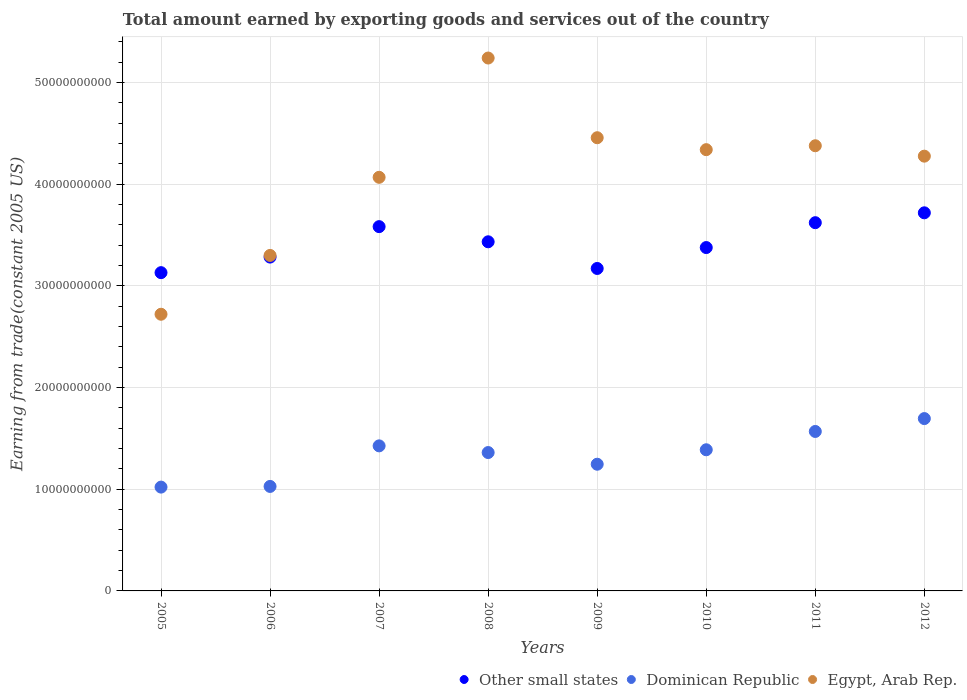What is the total amount earned by exporting goods and services in Egypt, Arab Rep. in 2012?
Make the answer very short. 4.28e+1. Across all years, what is the maximum total amount earned by exporting goods and services in Other small states?
Ensure brevity in your answer.  3.72e+1. Across all years, what is the minimum total amount earned by exporting goods and services in Egypt, Arab Rep.?
Offer a terse response. 2.72e+1. In which year was the total amount earned by exporting goods and services in Other small states maximum?
Keep it short and to the point. 2012. What is the total total amount earned by exporting goods and services in Other small states in the graph?
Make the answer very short. 2.73e+11. What is the difference between the total amount earned by exporting goods and services in Egypt, Arab Rep. in 2007 and that in 2008?
Keep it short and to the point. -1.17e+1. What is the difference between the total amount earned by exporting goods and services in Other small states in 2011 and the total amount earned by exporting goods and services in Dominican Republic in 2008?
Provide a short and direct response. 2.26e+1. What is the average total amount earned by exporting goods and services in Dominican Republic per year?
Your answer should be compact. 1.34e+1. In the year 2006, what is the difference between the total amount earned by exporting goods and services in Egypt, Arab Rep. and total amount earned by exporting goods and services in Other small states?
Your answer should be very brief. 1.63e+08. What is the ratio of the total amount earned by exporting goods and services in Other small states in 2009 to that in 2012?
Offer a terse response. 0.85. Is the total amount earned by exporting goods and services in Egypt, Arab Rep. in 2007 less than that in 2008?
Give a very brief answer. Yes. Is the difference between the total amount earned by exporting goods and services in Egypt, Arab Rep. in 2008 and 2010 greater than the difference between the total amount earned by exporting goods and services in Other small states in 2008 and 2010?
Ensure brevity in your answer.  Yes. What is the difference between the highest and the second highest total amount earned by exporting goods and services in Other small states?
Your response must be concise. 9.71e+08. What is the difference between the highest and the lowest total amount earned by exporting goods and services in Other small states?
Your answer should be compact. 5.89e+09. In how many years, is the total amount earned by exporting goods and services in Other small states greater than the average total amount earned by exporting goods and services in Other small states taken over all years?
Ensure brevity in your answer.  4. Is the sum of the total amount earned by exporting goods and services in Dominican Republic in 2009 and 2010 greater than the maximum total amount earned by exporting goods and services in Egypt, Arab Rep. across all years?
Keep it short and to the point. No. Is it the case that in every year, the sum of the total amount earned by exporting goods and services in Dominican Republic and total amount earned by exporting goods and services in Other small states  is greater than the total amount earned by exporting goods and services in Egypt, Arab Rep.?
Your answer should be very brief. No. Is the total amount earned by exporting goods and services in Dominican Republic strictly less than the total amount earned by exporting goods and services in Egypt, Arab Rep. over the years?
Your answer should be very brief. Yes. What is the difference between two consecutive major ticks on the Y-axis?
Give a very brief answer. 1.00e+1. Does the graph contain grids?
Provide a succinct answer. Yes. Where does the legend appear in the graph?
Make the answer very short. Bottom right. What is the title of the graph?
Give a very brief answer. Total amount earned by exporting goods and services out of the country. What is the label or title of the Y-axis?
Make the answer very short. Earning from trade(constant 2005 US). What is the Earning from trade(constant 2005 US) in Other small states in 2005?
Your answer should be compact. 3.13e+1. What is the Earning from trade(constant 2005 US) of Dominican Republic in 2005?
Provide a short and direct response. 1.02e+1. What is the Earning from trade(constant 2005 US) in Egypt, Arab Rep. in 2005?
Ensure brevity in your answer.  2.72e+1. What is the Earning from trade(constant 2005 US) in Other small states in 2006?
Make the answer very short. 3.28e+1. What is the Earning from trade(constant 2005 US) in Dominican Republic in 2006?
Offer a very short reply. 1.03e+1. What is the Earning from trade(constant 2005 US) of Egypt, Arab Rep. in 2006?
Your answer should be very brief. 3.30e+1. What is the Earning from trade(constant 2005 US) in Other small states in 2007?
Offer a very short reply. 3.58e+1. What is the Earning from trade(constant 2005 US) of Dominican Republic in 2007?
Make the answer very short. 1.43e+1. What is the Earning from trade(constant 2005 US) in Egypt, Arab Rep. in 2007?
Your answer should be very brief. 4.07e+1. What is the Earning from trade(constant 2005 US) of Other small states in 2008?
Your answer should be compact. 3.43e+1. What is the Earning from trade(constant 2005 US) in Dominican Republic in 2008?
Provide a short and direct response. 1.36e+1. What is the Earning from trade(constant 2005 US) in Egypt, Arab Rep. in 2008?
Keep it short and to the point. 5.24e+1. What is the Earning from trade(constant 2005 US) of Other small states in 2009?
Provide a succinct answer. 3.17e+1. What is the Earning from trade(constant 2005 US) in Dominican Republic in 2009?
Your response must be concise. 1.25e+1. What is the Earning from trade(constant 2005 US) of Egypt, Arab Rep. in 2009?
Your answer should be very brief. 4.46e+1. What is the Earning from trade(constant 2005 US) in Other small states in 2010?
Your answer should be very brief. 3.38e+1. What is the Earning from trade(constant 2005 US) of Dominican Republic in 2010?
Offer a very short reply. 1.39e+1. What is the Earning from trade(constant 2005 US) of Egypt, Arab Rep. in 2010?
Make the answer very short. 4.34e+1. What is the Earning from trade(constant 2005 US) of Other small states in 2011?
Offer a terse response. 3.62e+1. What is the Earning from trade(constant 2005 US) in Dominican Republic in 2011?
Keep it short and to the point. 1.57e+1. What is the Earning from trade(constant 2005 US) in Egypt, Arab Rep. in 2011?
Your answer should be compact. 4.38e+1. What is the Earning from trade(constant 2005 US) in Other small states in 2012?
Offer a terse response. 3.72e+1. What is the Earning from trade(constant 2005 US) of Dominican Republic in 2012?
Your response must be concise. 1.70e+1. What is the Earning from trade(constant 2005 US) of Egypt, Arab Rep. in 2012?
Your answer should be very brief. 4.28e+1. Across all years, what is the maximum Earning from trade(constant 2005 US) in Other small states?
Provide a short and direct response. 3.72e+1. Across all years, what is the maximum Earning from trade(constant 2005 US) in Dominican Republic?
Keep it short and to the point. 1.70e+1. Across all years, what is the maximum Earning from trade(constant 2005 US) in Egypt, Arab Rep.?
Make the answer very short. 5.24e+1. Across all years, what is the minimum Earning from trade(constant 2005 US) of Other small states?
Offer a terse response. 3.13e+1. Across all years, what is the minimum Earning from trade(constant 2005 US) in Dominican Republic?
Provide a short and direct response. 1.02e+1. Across all years, what is the minimum Earning from trade(constant 2005 US) in Egypt, Arab Rep.?
Ensure brevity in your answer.  2.72e+1. What is the total Earning from trade(constant 2005 US) in Other small states in the graph?
Offer a very short reply. 2.73e+11. What is the total Earning from trade(constant 2005 US) of Dominican Republic in the graph?
Provide a short and direct response. 1.07e+11. What is the total Earning from trade(constant 2005 US) in Egypt, Arab Rep. in the graph?
Your response must be concise. 3.28e+11. What is the difference between the Earning from trade(constant 2005 US) in Other small states in 2005 and that in 2006?
Offer a terse response. -1.53e+09. What is the difference between the Earning from trade(constant 2005 US) in Dominican Republic in 2005 and that in 2006?
Ensure brevity in your answer.  -6.68e+07. What is the difference between the Earning from trade(constant 2005 US) of Egypt, Arab Rep. in 2005 and that in 2006?
Make the answer very short. -5.79e+09. What is the difference between the Earning from trade(constant 2005 US) of Other small states in 2005 and that in 2007?
Offer a very short reply. -4.53e+09. What is the difference between the Earning from trade(constant 2005 US) in Dominican Republic in 2005 and that in 2007?
Your response must be concise. -4.06e+09. What is the difference between the Earning from trade(constant 2005 US) of Egypt, Arab Rep. in 2005 and that in 2007?
Provide a succinct answer. -1.35e+1. What is the difference between the Earning from trade(constant 2005 US) in Other small states in 2005 and that in 2008?
Ensure brevity in your answer.  -3.04e+09. What is the difference between the Earning from trade(constant 2005 US) of Dominican Republic in 2005 and that in 2008?
Give a very brief answer. -3.40e+09. What is the difference between the Earning from trade(constant 2005 US) in Egypt, Arab Rep. in 2005 and that in 2008?
Your answer should be very brief. -2.52e+1. What is the difference between the Earning from trade(constant 2005 US) in Other small states in 2005 and that in 2009?
Provide a succinct answer. -4.12e+08. What is the difference between the Earning from trade(constant 2005 US) in Dominican Republic in 2005 and that in 2009?
Provide a short and direct response. -2.25e+09. What is the difference between the Earning from trade(constant 2005 US) in Egypt, Arab Rep. in 2005 and that in 2009?
Give a very brief answer. -1.74e+1. What is the difference between the Earning from trade(constant 2005 US) in Other small states in 2005 and that in 2010?
Ensure brevity in your answer.  -2.47e+09. What is the difference between the Earning from trade(constant 2005 US) in Dominican Republic in 2005 and that in 2010?
Your answer should be compact. -3.67e+09. What is the difference between the Earning from trade(constant 2005 US) of Egypt, Arab Rep. in 2005 and that in 2010?
Your answer should be very brief. -1.62e+1. What is the difference between the Earning from trade(constant 2005 US) of Other small states in 2005 and that in 2011?
Ensure brevity in your answer.  -4.91e+09. What is the difference between the Earning from trade(constant 2005 US) in Dominican Republic in 2005 and that in 2011?
Make the answer very short. -5.47e+09. What is the difference between the Earning from trade(constant 2005 US) of Egypt, Arab Rep. in 2005 and that in 2011?
Make the answer very short. -1.66e+1. What is the difference between the Earning from trade(constant 2005 US) of Other small states in 2005 and that in 2012?
Ensure brevity in your answer.  -5.89e+09. What is the difference between the Earning from trade(constant 2005 US) in Dominican Republic in 2005 and that in 2012?
Ensure brevity in your answer.  -6.74e+09. What is the difference between the Earning from trade(constant 2005 US) in Egypt, Arab Rep. in 2005 and that in 2012?
Provide a succinct answer. -1.56e+1. What is the difference between the Earning from trade(constant 2005 US) of Other small states in 2006 and that in 2007?
Keep it short and to the point. -2.99e+09. What is the difference between the Earning from trade(constant 2005 US) of Dominican Republic in 2006 and that in 2007?
Your answer should be compact. -3.99e+09. What is the difference between the Earning from trade(constant 2005 US) in Egypt, Arab Rep. in 2006 and that in 2007?
Provide a short and direct response. -7.68e+09. What is the difference between the Earning from trade(constant 2005 US) in Other small states in 2006 and that in 2008?
Provide a succinct answer. -1.50e+09. What is the difference between the Earning from trade(constant 2005 US) in Dominican Republic in 2006 and that in 2008?
Make the answer very short. -3.33e+09. What is the difference between the Earning from trade(constant 2005 US) of Egypt, Arab Rep. in 2006 and that in 2008?
Give a very brief answer. -1.94e+1. What is the difference between the Earning from trade(constant 2005 US) in Other small states in 2006 and that in 2009?
Make the answer very short. 1.12e+09. What is the difference between the Earning from trade(constant 2005 US) in Dominican Republic in 2006 and that in 2009?
Make the answer very short. -2.18e+09. What is the difference between the Earning from trade(constant 2005 US) in Egypt, Arab Rep. in 2006 and that in 2009?
Provide a succinct answer. -1.16e+1. What is the difference between the Earning from trade(constant 2005 US) of Other small states in 2006 and that in 2010?
Your answer should be compact. -9.37e+08. What is the difference between the Earning from trade(constant 2005 US) of Dominican Republic in 2006 and that in 2010?
Your response must be concise. -3.61e+09. What is the difference between the Earning from trade(constant 2005 US) of Egypt, Arab Rep. in 2006 and that in 2010?
Your answer should be compact. -1.04e+1. What is the difference between the Earning from trade(constant 2005 US) in Other small states in 2006 and that in 2011?
Provide a succinct answer. -3.38e+09. What is the difference between the Earning from trade(constant 2005 US) of Dominican Republic in 2006 and that in 2011?
Keep it short and to the point. -5.41e+09. What is the difference between the Earning from trade(constant 2005 US) of Egypt, Arab Rep. in 2006 and that in 2011?
Give a very brief answer. -1.08e+1. What is the difference between the Earning from trade(constant 2005 US) of Other small states in 2006 and that in 2012?
Provide a short and direct response. -4.35e+09. What is the difference between the Earning from trade(constant 2005 US) in Dominican Republic in 2006 and that in 2012?
Your answer should be very brief. -6.67e+09. What is the difference between the Earning from trade(constant 2005 US) in Egypt, Arab Rep. in 2006 and that in 2012?
Your response must be concise. -9.76e+09. What is the difference between the Earning from trade(constant 2005 US) in Other small states in 2007 and that in 2008?
Provide a short and direct response. 1.49e+09. What is the difference between the Earning from trade(constant 2005 US) in Dominican Republic in 2007 and that in 2008?
Give a very brief answer. 6.58e+08. What is the difference between the Earning from trade(constant 2005 US) in Egypt, Arab Rep. in 2007 and that in 2008?
Offer a terse response. -1.17e+1. What is the difference between the Earning from trade(constant 2005 US) of Other small states in 2007 and that in 2009?
Provide a short and direct response. 4.11e+09. What is the difference between the Earning from trade(constant 2005 US) of Dominican Republic in 2007 and that in 2009?
Provide a succinct answer. 1.81e+09. What is the difference between the Earning from trade(constant 2005 US) of Egypt, Arab Rep. in 2007 and that in 2009?
Make the answer very short. -3.89e+09. What is the difference between the Earning from trade(constant 2005 US) in Other small states in 2007 and that in 2010?
Your answer should be very brief. 2.06e+09. What is the difference between the Earning from trade(constant 2005 US) of Dominican Republic in 2007 and that in 2010?
Give a very brief answer. 3.84e+08. What is the difference between the Earning from trade(constant 2005 US) in Egypt, Arab Rep. in 2007 and that in 2010?
Offer a very short reply. -2.72e+09. What is the difference between the Earning from trade(constant 2005 US) in Other small states in 2007 and that in 2011?
Offer a very short reply. -3.89e+08. What is the difference between the Earning from trade(constant 2005 US) of Dominican Republic in 2007 and that in 2011?
Offer a very short reply. -1.42e+09. What is the difference between the Earning from trade(constant 2005 US) of Egypt, Arab Rep. in 2007 and that in 2011?
Offer a terse response. -3.10e+09. What is the difference between the Earning from trade(constant 2005 US) in Other small states in 2007 and that in 2012?
Make the answer very short. -1.36e+09. What is the difference between the Earning from trade(constant 2005 US) in Dominican Republic in 2007 and that in 2012?
Offer a terse response. -2.68e+09. What is the difference between the Earning from trade(constant 2005 US) of Egypt, Arab Rep. in 2007 and that in 2012?
Make the answer very short. -2.08e+09. What is the difference between the Earning from trade(constant 2005 US) of Other small states in 2008 and that in 2009?
Ensure brevity in your answer.  2.62e+09. What is the difference between the Earning from trade(constant 2005 US) of Dominican Republic in 2008 and that in 2009?
Give a very brief answer. 1.15e+09. What is the difference between the Earning from trade(constant 2005 US) of Egypt, Arab Rep. in 2008 and that in 2009?
Provide a short and direct response. 7.84e+09. What is the difference between the Earning from trade(constant 2005 US) of Other small states in 2008 and that in 2010?
Offer a terse response. 5.67e+08. What is the difference between the Earning from trade(constant 2005 US) in Dominican Republic in 2008 and that in 2010?
Provide a short and direct response. -2.73e+08. What is the difference between the Earning from trade(constant 2005 US) of Egypt, Arab Rep. in 2008 and that in 2010?
Give a very brief answer. 9.01e+09. What is the difference between the Earning from trade(constant 2005 US) in Other small states in 2008 and that in 2011?
Make the answer very short. -1.88e+09. What is the difference between the Earning from trade(constant 2005 US) in Dominican Republic in 2008 and that in 2011?
Offer a very short reply. -2.07e+09. What is the difference between the Earning from trade(constant 2005 US) of Egypt, Arab Rep. in 2008 and that in 2011?
Provide a succinct answer. 8.63e+09. What is the difference between the Earning from trade(constant 2005 US) in Other small states in 2008 and that in 2012?
Provide a succinct answer. -2.85e+09. What is the difference between the Earning from trade(constant 2005 US) in Dominican Republic in 2008 and that in 2012?
Your answer should be very brief. -3.34e+09. What is the difference between the Earning from trade(constant 2005 US) in Egypt, Arab Rep. in 2008 and that in 2012?
Provide a short and direct response. 9.65e+09. What is the difference between the Earning from trade(constant 2005 US) in Other small states in 2009 and that in 2010?
Provide a succinct answer. -2.06e+09. What is the difference between the Earning from trade(constant 2005 US) of Dominican Republic in 2009 and that in 2010?
Your answer should be compact. -1.42e+09. What is the difference between the Earning from trade(constant 2005 US) in Egypt, Arab Rep. in 2009 and that in 2010?
Ensure brevity in your answer.  1.17e+09. What is the difference between the Earning from trade(constant 2005 US) in Other small states in 2009 and that in 2011?
Your answer should be very brief. -4.50e+09. What is the difference between the Earning from trade(constant 2005 US) in Dominican Republic in 2009 and that in 2011?
Provide a short and direct response. -3.22e+09. What is the difference between the Earning from trade(constant 2005 US) of Egypt, Arab Rep. in 2009 and that in 2011?
Offer a terse response. 7.90e+08. What is the difference between the Earning from trade(constant 2005 US) in Other small states in 2009 and that in 2012?
Your answer should be very brief. -5.47e+09. What is the difference between the Earning from trade(constant 2005 US) of Dominican Republic in 2009 and that in 2012?
Ensure brevity in your answer.  -4.49e+09. What is the difference between the Earning from trade(constant 2005 US) of Egypt, Arab Rep. in 2009 and that in 2012?
Provide a succinct answer. 1.81e+09. What is the difference between the Earning from trade(constant 2005 US) in Other small states in 2010 and that in 2011?
Keep it short and to the point. -2.45e+09. What is the difference between the Earning from trade(constant 2005 US) in Dominican Republic in 2010 and that in 2011?
Your answer should be very brief. -1.80e+09. What is the difference between the Earning from trade(constant 2005 US) in Egypt, Arab Rep. in 2010 and that in 2011?
Ensure brevity in your answer.  -3.85e+08. What is the difference between the Earning from trade(constant 2005 US) of Other small states in 2010 and that in 2012?
Keep it short and to the point. -3.42e+09. What is the difference between the Earning from trade(constant 2005 US) in Dominican Republic in 2010 and that in 2012?
Your response must be concise. -3.07e+09. What is the difference between the Earning from trade(constant 2005 US) of Egypt, Arab Rep. in 2010 and that in 2012?
Give a very brief answer. 6.38e+08. What is the difference between the Earning from trade(constant 2005 US) of Other small states in 2011 and that in 2012?
Your response must be concise. -9.71e+08. What is the difference between the Earning from trade(constant 2005 US) of Dominican Republic in 2011 and that in 2012?
Give a very brief answer. -1.27e+09. What is the difference between the Earning from trade(constant 2005 US) in Egypt, Arab Rep. in 2011 and that in 2012?
Your response must be concise. 1.02e+09. What is the difference between the Earning from trade(constant 2005 US) in Other small states in 2005 and the Earning from trade(constant 2005 US) in Dominican Republic in 2006?
Keep it short and to the point. 2.10e+1. What is the difference between the Earning from trade(constant 2005 US) of Other small states in 2005 and the Earning from trade(constant 2005 US) of Egypt, Arab Rep. in 2006?
Your answer should be compact. -1.69e+09. What is the difference between the Earning from trade(constant 2005 US) of Dominican Republic in 2005 and the Earning from trade(constant 2005 US) of Egypt, Arab Rep. in 2006?
Give a very brief answer. -2.28e+1. What is the difference between the Earning from trade(constant 2005 US) of Other small states in 2005 and the Earning from trade(constant 2005 US) of Dominican Republic in 2007?
Provide a succinct answer. 1.70e+1. What is the difference between the Earning from trade(constant 2005 US) in Other small states in 2005 and the Earning from trade(constant 2005 US) in Egypt, Arab Rep. in 2007?
Your answer should be very brief. -9.38e+09. What is the difference between the Earning from trade(constant 2005 US) of Dominican Republic in 2005 and the Earning from trade(constant 2005 US) of Egypt, Arab Rep. in 2007?
Provide a succinct answer. -3.05e+1. What is the difference between the Earning from trade(constant 2005 US) in Other small states in 2005 and the Earning from trade(constant 2005 US) in Dominican Republic in 2008?
Ensure brevity in your answer.  1.77e+1. What is the difference between the Earning from trade(constant 2005 US) in Other small states in 2005 and the Earning from trade(constant 2005 US) in Egypt, Arab Rep. in 2008?
Provide a short and direct response. -2.11e+1. What is the difference between the Earning from trade(constant 2005 US) in Dominican Republic in 2005 and the Earning from trade(constant 2005 US) in Egypt, Arab Rep. in 2008?
Ensure brevity in your answer.  -4.22e+1. What is the difference between the Earning from trade(constant 2005 US) of Other small states in 2005 and the Earning from trade(constant 2005 US) of Dominican Republic in 2009?
Give a very brief answer. 1.88e+1. What is the difference between the Earning from trade(constant 2005 US) in Other small states in 2005 and the Earning from trade(constant 2005 US) in Egypt, Arab Rep. in 2009?
Your answer should be compact. -1.33e+1. What is the difference between the Earning from trade(constant 2005 US) of Dominican Republic in 2005 and the Earning from trade(constant 2005 US) of Egypt, Arab Rep. in 2009?
Your answer should be compact. -3.44e+1. What is the difference between the Earning from trade(constant 2005 US) in Other small states in 2005 and the Earning from trade(constant 2005 US) in Dominican Republic in 2010?
Your response must be concise. 1.74e+1. What is the difference between the Earning from trade(constant 2005 US) of Other small states in 2005 and the Earning from trade(constant 2005 US) of Egypt, Arab Rep. in 2010?
Your answer should be very brief. -1.21e+1. What is the difference between the Earning from trade(constant 2005 US) of Dominican Republic in 2005 and the Earning from trade(constant 2005 US) of Egypt, Arab Rep. in 2010?
Keep it short and to the point. -3.32e+1. What is the difference between the Earning from trade(constant 2005 US) of Other small states in 2005 and the Earning from trade(constant 2005 US) of Dominican Republic in 2011?
Your response must be concise. 1.56e+1. What is the difference between the Earning from trade(constant 2005 US) in Other small states in 2005 and the Earning from trade(constant 2005 US) in Egypt, Arab Rep. in 2011?
Make the answer very short. -1.25e+1. What is the difference between the Earning from trade(constant 2005 US) of Dominican Republic in 2005 and the Earning from trade(constant 2005 US) of Egypt, Arab Rep. in 2011?
Ensure brevity in your answer.  -3.36e+1. What is the difference between the Earning from trade(constant 2005 US) of Other small states in 2005 and the Earning from trade(constant 2005 US) of Dominican Republic in 2012?
Your answer should be compact. 1.44e+1. What is the difference between the Earning from trade(constant 2005 US) of Other small states in 2005 and the Earning from trade(constant 2005 US) of Egypt, Arab Rep. in 2012?
Offer a very short reply. -1.15e+1. What is the difference between the Earning from trade(constant 2005 US) of Dominican Republic in 2005 and the Earning from trade(constant 2005 US) of Egypt, Arab Rep. in 2012?
Keep it short and to the point. -3.26e+1. What is the difference between the Earning from trade(constant 2005 US) in Other small states in 2006 and the Earning from trade(constant 2005 US) in Dominican Republic in 2007?
Your response must be concise. 1.86e+1. What is the difference between the Earning from trade(constant 2005 US) of Other small states in 2006 and the Earning from trade(constant 2005 US) of Egypt, Arab Rep. in 2007?
Keep it short and to the point. -7.85e+09. What is the difference between the Earning from trade(constant 2005 US) in Dominican Republic in 2006 and the Earning from trade(constant 2005 US) in Egypt, Arab Rep. in 2007?
Provide a short and direct response. -3.04e+1. What is the difference between the Earning from trade(constant 2005 US) in Other small states in 2006 and the Earning from trade(constant 2005 US) in Dominican Republic in 2008?
Make the answer very short. 1.92e+1. What is the difference between the Earning from trade(constant 2005 US) of Other small states in 2006 and the Earning from trade(constant 2005 US) of Egypt, Arab Rep. in 2008?
Provide a short and direct response. -1.96e+1. What is the difference between the Earning from trade(constant 2005 US) in Dominican Republic in 2006 and the Earning from trade(constant 2005 US) in Egypt, Arab Rep. in 2008?
Provide a short and direct response. -4.21e+1. What is the difference between the Earning from trade(constant 2005 US) in Other small states in 2006 and the Earning from trade(constant 2005 US) in Dominican Republic in 2009?
Your answer should be very brief. 2.04e+1. What is the difference between the Earning from trade(constant 2005 US) of Other small states in 2006 and the Earning from trade(constant 2005 US) of Egypt, Arab Rep. in 2009?
Offer a terse response. -1.17e+1. What is the difference between the Earning from trade(constant 2005 US) of Dominican Republic in 2006 and the Earning from trade(constant 2005 US) of Egypt, Arab Rep. in 2009?
Offer a very short reply. -3.43e+1. What is the difference between the Earning from trade(constant 2005 US) in Other small states in 2006 and the Earning from trade(constant 2005 US) in Dominican Republic in 2010?
Offer a terse response. 1.90e+1. What is the difference between the Earning from trade(constant 2005 US) in Other small states in 2006 and the Earning from trade(constant 2005 US) in Egypt, Arab Rep. in 2010?
Ensure brevity in your answer.  -1.06e+1. What is the difference between the Earning from trade(constant 2005 US) of Dominican Republic in 2006 and the Earning from trade(constant 2005 US) of Egypt, Arab Rep. in 2010?
Make the answer very short. -3.31e+1. What is the difference between the Earning from trade(constant 2005 US) in Other small states in 2006 and the Earning from trade(constant 2005 US) in Dominican Republic in 2011?
Provide a short and direct response. 1.72e+1. What is the difference between the Earning from trade(constant 2005 US) of Other small states in 2006 and the Earning from trade(constant 2005 US) of Egypt, Arab Rep. in 2011?
Your answer should be very brief. -1.10e+1. What is the difference between the Earning from trade(constant 2005 US) of Dominican Republic in 2006 and the Earning from trade(constant 2005 US) of Egypt, Arab Rep. in 2011?
Provide a short and direct response. -3.35e+1. What is the difference between the Earning from trade(constant 2005 US) of Other small states in 2006 and the Earning from trade(constant 2005 US) of Dominican Republic in 2012?
Give a very brief answer. 1.59e+1. What is the difference between the Earning from trade(constant 2005 US) in Other small states in 2006 and the Earning from trade(constant 2005 US) in Egypt, Arab Rep. in 2012?
Your response must be concise. -9.93e+09. What is the difference between the Earning from trade(constant 2005 US) of Dominican Republic in 2006 and the Earning from trade(constant 2005 US) of Egypt, Arab Rep. in 2012?
Offer a terse response. -3.25e+1. What is the difference between the Earning from trade(constant 2005 US) in Other small states in 2007 and the Earning from trade(constant 2005 US) in Dominican Republic in 2008?
Your answer should be compact. 2.22e+1. What is the difference between the Earning from trade(constant 2005 US) of Other small states in 2007 and the Earning from trade(constant 2005 US) of Egypt, Arab Rep. in 2008?
Ensure brevity in your answer.  -1.66e+1. What is the difference between the Earning from trade(constant 2005 US) of Dominican Republic in 2007 and the Earning from trade(constant 2005 US) of Egypt, Arab Rep. in 2008?
Provide a succinct answer. -3.81e+1. What is the difference between the Earning from trade(constant 2005 US) in Other small states in 2007 and the Earning from trade(constant 2005 US) in Dominican Republic in 2009?
Provide a short and direct response. 2.34e+1. What is the difference between the Earning from trade(constant 2005 US) of Other small states in 2007 and the Earning from trade(constant 2005 US) of Egypt, Arab Rep. in 2009?
Keep it short and to the point. -8.75e+09. What is the difference between the Earning from trade(constant 2005 US) of Dominican Republic in 2007 and the Earning from trade(constant 2005 US) of Egypt, Arab Rep. in 2009?
Provide a succinct answer. -3.03e+1. What is the difference between the Earning from trade(constant 2005 US) in Other small states in 2007 and the Earning from trade(constant 2005 US) in Dominican Republic in 2010?
Ensure brevity in your answer.  2.19e+1. What is the difference between the Earning from trade(constant 2005 US) of Other small states in 2007 and the Earning from trade(constant 2005 US) of Egypt, Arab Rep. in 2010?
Keep it short and to the point. -7.57e+09. What is the difference between the Earning from trade(constant 2005 US) of Dominican Republic in 2007 and the Earning from trade(constant 2005 US) of Egypt, Arab Rep. in 2010?
Ensure brevity in your answer.  -2.91e+1. What is the difference between the Earning from trade(constant 2005 US) of Other small states in 2007 and the Earning from trade(constant 2005 US) of Dominican Republic in 2011?
Your answer should be very brief. 2.01e+1. What is the difference between the Earning from trade(constant 2005 US) of Other small states in 2007 and the Earning from trade(constant 2005 US) of Egypt, Arab Rep. in 2011?
Make the answer very short. -7.96e+09. What is the difference between the Earning from trade(constant 2005 US) of Dominican Republic in 2007 and the Earning from trade(constant 2005 US) of Egypt, Arab Rep. in 2011?
Your response must be concise. -2.95e+1. What is the difference between the Earning from trade(constant 2005 US) of Other small states in 2007 and the Earning from trade(constant 2005 US) of Dominican Republic in 2012?
Offer a terse response. 1.89e+1. What is the difference between the Earning from trade(constant 2005 US) of Other small states in 2007 and the Earning from trade(constant 2005 US) of Egypt, Arab Rep. in 2012?
Provide a short and direct response. -6.93e+09. What is the difference between the Earning from trade(constant 2005 US) of Dominican Republic in 2007 and the Earning from trade(constant 2005 US) of Egypt, Arab Rep. in 2012?
Offer a very short reply. -2.85e+1. What is the difference between the Earning from trade(constant 2005 US) of Other small states in 2008 and the Earning from trade(constant 2005 US) of Dominican Republic in 2009?
Provide a short and direct response. 2.19e+1. What is the difference between the Earning from trade(constant 2005 US) in Other small states in 2008 and the Earning from trade(constant 2005 US) in Egypt, Arab Rep. in 2009?
Make the answer very short. -1.02e+1. What is the difference between the Earning from trade(constant 2005 US) in Dominican Republic in 2008 and the Earning from trade(constant 2005 US) in Egypt, Arab Rep. in 2009?
Your answer should be compact. -3.10e+1. What is the difference between the Earning from trade(constant 2005 US) of Other small states in 2008 and the Earning from trade(constant 2005 US) of Dominican Republic in 2010?
Give a very brief answer. 2.05e+1. What is the difference between the Earning from trade(constant 2005 US) of Other small states in 2008 and the Earning from trade(constant 2005 US) of Egypt, Arab Rep. in 2010?
Your answer should be very brief. -9.06e+09. What is the difference between the Earning from trade(constant 2005 US) of Dominican Republic in 2008 and the Earning from trade(constant 2005 US) of Egypt, Arab Rep. in 2010?
Your response must be concise. -2.98e+1. What is the difference between the Earning from trade(constant 2005 US) of Other small states in 2008 and the Earning from trade(constant 2005 US) of Dominican Republic in 2011?
Offer a very short reply. 1.87e+1. What is the difference between the Earning from trade(constant 2005 US) of Other small states in 2008 and the Earning from trade(constant 2005 US) of Egypt, Arab Rep. in 2011?
Keep it short and to the point. -9.45e+09. What is the difference between the Earning from trade(constant 2005 US) of Dominican Republic in 2008 and the Earning from trade(constant 2005 US) of Egypt, Arab Rep. in 2011?
Your response must be concise. -3.02e+1. What is the difference between the Earning from trade(constant 2005 US) of Other small states in 2008 and the Earning from trade(constant 2005 US) of Dominican Republic in 2012?
Provide a succinct answer. 1.74e+1. What is the difference between the Earning from trade(constant 2005 US) of Other small states in 2008 and the Earning from trade(constant 2005 US) of Egypt, Arab Rep. in 2012?
Provide a short and direct response. -8.42e+09. What is the difference between the Earning from trade(constant 2005 US) in Dominican Republic in 2008 and the Earning from trade(constant 2005 US) in Egypt, Arab Rep. in 2012?
Give a very brief answer. -2.92e+1. What is the difference between the Earning from trade(constant 2005 US) in Other small states in 2009 and the Earning from trade(constant 2005 US) in Dominican Republic in 2010?
Provide a succinct answer. 1.78e+1. What is the difference between the Earning from trade(constant 2005 US) in Other small states in 2009 and the Earning from trade(constant 2005 US) in Egypt, Arab Rep. in 2010?
Make the answer very short. -1.17e+1. What is the difference between the Earning from trade(constant 2005 US) of Dominican Republic in 2009 and the Earning from trade(constant 2005 US) of Egypt, Arab Rep. in 2010?
Ensure brevity in your answer.  -3.09e+1. What is the difference between the Earning from trade(constant 2005 US) in Other small states in 2009 and the Earning from trade(constant 2005 US) in Dominican Republic in 2011?
Your answer should be very brief. 1.60e+1. What is the difference between the Earning from trade(constant 2005 US) in Other small states in 2009 and the Earning from trade(constant 2005 US) in Egypt, Arab Rep. in 2011?
Your answer should be very brief. -1.21e+1. What is the difference between the Earning from trade(constant 2005 US) in Dominican Republic in 2009 and the Earning from trade(constant 2005 US) in Egypt, Arab Rep. in 2011?
Make the answer very short. -3.13e+1. What is the difference between the Earning from trade(constant 2005 US) of Other small states in 2009 and the Earning from trade(constant 2005 US) of Dominican Republic in 2012?
Provide a short and direct response. 1.48e+1. What is the difference between the Earning from trade(constant 2005 US) in Other small states in 2009 and the Earning from trade(constant 2005 US) in Egypt, Arab Rep. in 2012?
Your answer should be very brief. -1.10e+1. What is the difference between the Earning from trade(constant 2005 US) in Dominican Republic in 2009 and the Earning from trade(constant 2005 US) in Egypt, Arab Rep. in 2012?
Make the answer very short. -3.03e+1. What is the difference between the Earning from trade(constant 2005 US) in Other small states in 2010 and the Earning from trade(constant 2005 US) in Dominican Republic in 2011?
Your response must be concise. 1.81e+1. What is the difference between the Earning from trade(constant 2005 US) in Other small states in 2010 and the Earning from trade(constant 2005 US) in Egypt, Arab Rep. in 2011?
Your answer should be compact. -1.00e+1. What is the difference between the Earning from trade(constant 2005 US) of Dominican Republic in 2010 and the Earning from trade(constant 2005 US) of Egypt, Arab Rep. in 2011?
Provide a succinct answer. -2.99e+1. What is the difference between the Earning from trade(constant 2005 US) of Other small states in 2010 and the Earning from trade(constant 2005 US) of Dominican Republic in 2012?
Provide a succinct answer. 1.68e+1. What is the difference between the Earning from trade(constant 2005 US) of Other small states in 2010 and the Earning from trade(constant 2005 US) of Egypt, Arab Rep. in 2012?
Offer a terse response. -8.99e+09. What is the difference between the Earning from trade(constant 2005 US) in Dominican Republic in 2010 and the Earning from trade(constant 2005 US) in Egypt, Arab Rep. in 2012?
Keep it short and to the point. -2.89e+1. What is the difference between the Earning from trade(constant 2005 US) of Other small states in 2011 and the Earning from trade(constant 2005 US) of Dominican Republic in 2012?
Give a very brief answer. 1.93e+1. What is the difference between the Earning from trade(constant 2005 US) in Other small states in 2011 and the Earning from trade(constant 2005 US) in Egypt, Arab Rep. in 2012?
Ensure brevity in your answer.  -6.54e+09. What is the difference between the Earning from trade(constant 2005 US) in Dominican Republic in 2011 and the Earning from trade(constant 2005 US) in Egypt, Arab Rep. in 2012?
Make the answer very short. -2.71e+1. What is the average Earning from trade(constant 2005 US) of Other small states per year?
Offer a very short reply. 3.42e+1. What is the average Earning from trade(constant 2005 US) in Dominican Republic per year?
Offer a terse response. 1.34e+1. What is the average Earning from trade(constant 2005 US) in Egypt, Arab Rep. per year?
Give a very brief answer. 4.10e+1. In the year 2005, what is the difference between the Earning from trade(constant 2005 US) in Other small states and Earning from trade(constant 2005 US) in Dominican Republic?
Your response must be concise. 2.11e+1. In the year 2005, what is the difference between the Earning from trade(constant 2005 US) in Other small states and Earning from trade(constant 2005 US) in Egypt, Arab Rep.?
Offer a very short reply. 4.09e+09. In the year 2005, what is the difference between the Earning from trade(constant 2005 US) in Dominican Republic and Earning from trade(constant 2005 US) in Egypt, Arab Rep.?
Offer a very short reply. -1.70e+1. In the year 2006, what is the difference between the Earning from trade(constant 2005 US) of Other small states and Earning from trade(constant 2005 US) of Dominican Republic?
Your answer should be very brief. 2.26e+1. In the year 2006, what is the difference between the Earning from trade(constant 2005 US) in Other small states and Earning from trade(constant 2005 US) in Egypt, Arab Rep.?
Your answer should be compact. -1.63e+08. In the year 2006, what is the difference between the Earning from trade(constant 2005 US) in Dominican Republic and Earning from trade(constant 2005 US) in Egypt, Arab Rep.?
Offer a very short reply. -2.27e+1. In the year 2007, what is the difference between the Earning from trade(constant 2005 US) in Other small states and Earning from trade(constant 2005 US) in Dominican Republic?
Your answer should be compact. 2.16e+1. In the year 2007, what is the difference between the Earning from trade(constant 2005 US) of Other small states and Earning from trade(constant 2005 US) of Egypt, Arab Rep.?
Provide a short and direct response. -4.85e+09. In the year 2007, what is the difference between the Earning from trade(constant 2005 US) in Dominican Republic and Earning from trade(constant 2005 US) in Egypt, Arab Rep.?
Provide a succinct answer. -2.64e+1. In the year 2008, what is the difference between the Earning from trade(constant 2005 US) of Other small states and Earning from trade(constant 2005 US) of Dominican Republic?
Ensure brevity in your answer.  2.07e+1. In the year 2008, what is the difference between the Earning from trade(constant 2005 US) of Other small states and Earning from trade(constant 2005 US) of Egypt, Arab Rep.?
Your answer should be very brief. -1.81e+1. In the year 2008, what is the difference between the Earning from trade(constant 2005 US) in Dominican Republic and Earning from trade(constant 2005 US) in Egypt, Arab Rep.?
Your response must be concise. -3.88e+1. In the year 2009, what is the difference between the Earning from trade(constant 2005 US) in Other small states and Earning from trade(constant 2005 US) in Dominican Republic?
Give a very brief answer. 1.93e+1. In the year 2009, what is the difference between the Earning from trade(constant 2005 US) in Other small states and Earning from trade(constant 2005 US) in Egypt, Arab Rep.?
Give a very brief answer. -1.29e+1. In the year 2009, what is the difference between the Earning from trade(constant 2005 US) of Dominican Republic and Earning from trade(constant 2005 US) of Egypt, Arab Rep.?
Your answer should be compact. -3.21e+1. In the year 2010, what is the difference between the Earning from trade(constant 2005 US) in Other small states and Earning from trade(constant 2005 US) in Dominican Republic?
Ensure brevity in your answer.  1.99e+1. In the year 2010, what is the difference between the Earning from trade(constant 2005 US) in Other small states and Earning from trade(constant 2005 US) in Egypt, Arab Rep.?
Give a very brief answer. -9.63e+09. In the year 2010, what is the difference between the Earning from trade(constant 2005 US) in Dominican Republic and Earning from trade(constant 2005 US) in Egypt, Arab Rep.?
Offer a very short reply. -2.95e+1. In the year 2011, what is the difference between the Earning from trade(constant 2005 US) of Other small states and Earning from trade(constant 2005 US) of Dominican Republic?
Ensure brevity in your answer.  2.05e+1. In the year 2011, what is the difference between the Earning from trade(constant 2005 US) in Other small states and Earning from trade(constant 2005 US) in Egypt, Arab Rep.?
Provide a succinct answer. -7.57e+09. In the year 2011, what is the difference between the Earning from trade(constant 2005 US) in Dominican Republic and Earning from trade(constant 2005 US) in Egypt, Arab Rep.?
Offer a terse response. -2.81e+1. In the year 2012, what is the difference between the Earning from trade(constant 2005 US) in Other small states and Earning from trade(constant 2005 US) in Dominican Republic?
Your response must be concise. 2.02e+1. In the year 2012, what is the difference between the Earning from trade(constant 2005 US) in Other small states and Earning from trade(constant 2005 US) in Egypt, Arab Rep.?
Provide a succinct answer. -5.57e+09. In the year 2012, what is the difference between the Earning from trade(constant 2005 US) of Dominican Republic and Earning from trade(constant 2005 US) of Egypt, Arab Rep.?
Provide a succinct answer. -2.58e+1. What is the ratio of the Earning from trade(constant 2005 US) in Other small states in 2005 to that in 2006?
Provide a succinct answer. 0.95. What is the ratio of the Earning from trade(constant 2005 US) in Egypt, Arab Rep. in 2005 to that in 2006?
Keep it short and to the point. 0.82. What is the ratio of the Earning from trade(constant 2005 US) of Other small states in 2005 to that in 2007?
Offer a terse response. 0.87. What is the ratio of the Earning from trade(constant 2005 US) in Dominican Republic in 2005 to that in 2007?
Give a very brief answer. 0.72. What is the ratio of the Earning from trade(constant 2005 US) in Egypt, Arab Rep. in 2005 to that in 2007?
Offer a terse response. 0.67. What is the ratio of the Earning from trade(constant 2005 US) of Other small states in 2005 to that in 2008?
Ensure brevity in your answer.  0.91. What is the ratio of the Earning from trade(constant 2005 US) in Dominican Republic in 2005 to that in 2008?
Offer a very short reply. 0.75. What is the ratio of the Earning from trade(constant 2005 US) in Egypt, Arab Rep. in 2005 to that in 2008?
Your answer should be compact. 0.52. What is the ratio of the Earning from trade(constant 2005 US) in Dominican Republic in 2005 to that in 2009?
Your response must be concise. 0.82. What is the ratio of the Earning from trade(constant 2005 US) in Egypt, Arab Rep. in 2005 to that in 2009?
Offer a terse response. 0.61. What is the ratio of the Earning from trade(constant 2005 US) in Other small states in 2005 to that in 2010?
Your response must be concise. 0.93. What is the ratio of the Earning from trade(constant 2005 US) of Dominican Republic in 2005 to that in 2010?
Provide a short and direct response. 0.74. What is the ratio of the Earning from trade(constant 2005 US) of Egypt, Arab Rep. in 2005 to that in 2010?
Make the answer very short. 0.63. What is the ratio of the Earning from trade(constant 2005 US) in Other small states in 2005 to that in 2011?
Your response must be concise. 0.86. What is the ratio of the Earning from trade(constant 2005 US) of Dominican Republic in 2005 to that in 2011?
Offer a terse response. 0.65. What is the ratio of the Earning from trade(constant 2005 US) of Egypt, Arab Rep. in 2005 to that in 2011?
Keep it short and to the point. 0.62. What is the ratio of the Earning from trade(constant 2005 US) of Other small states in 2005 to that in 2012?
Ensure brevity in your answer.  0.84. What is the ratio of the Earning from trade(constant 2005 US) in Dominican Republic in 2005 to that in 2012?
Keep it short and to the point. 0.6. What is the ratio of the Earning from trade(constant 2005 US) in Egypt, Arab Rep. in 2005 to that in 2012?
Ensure brevity in your answer.  0.64. What is the ratio of the Earning from trade(constant 2005 US) in Other small states in 2006 to that in 2007?
Your answer should be very brief. 0.92. What is the ratio of the Earning from trade(constant 2005 US) of Dominican Republic in 2006 to that in 2007?
Offer a very short reply. 0.72. What is the ratio of the Earning from trade(constant 2005 US) of Egypt, Arab Rep. in 2006 to that in 2007?
Make the answer very short. 0.81. What is the ratio of the Earning from trade(constant 2005 US) in Other small states in 2006 to that in 2008?
Provide a succinct answer. 0.96. What is the ratio of the Earning from trade(constant 2005 US) in Dominican Republic in 2006 to that in 2008?
Your answer should be very brief. 0.76. What is the ratio of the Earning from trade(constant 2005 US) of Egypt, Arab Rep. in 2006 to that in 2008?
Your answer should be compact. 0.63. What is the ratio of the Earning from trade(constant 2005 US) in Other small states in 2006 to that in 2009?
Offer a very short reply. 1.04. What is the ratio of the Earning from trade(constant 2005 US) in Dominican Republic in 2006 to that in 2009?
Offer a terse response. 0.82. What is the ratio of the Earning from trade(constant 2005 US) of Egypt, Arab Rep. in 2006 to that in 2009?
Offer a terse response. 0.74. What is the ratio of the Earning from trade(constant 2005 US) of Other small states in 2006 to that in 2010?
Provide a short and direct response. 0.97. What is the ratio of the Earning from trade(constant 2005 US) of Dominican Republic in 2006 to that in 2010?
Your answer should be compact. 0.74. What is the ratio of the Earning from trade(constant 2005 US) of Egypt, Arab Rep. in 2006 to that in 2010?
Keep it short and to the point. 0.76. What is the ratio of the Earning from trade(constant 2005 US) of Other small states in 2006 to that in 2011?
Your response must be concise. 0.91. What is the ratio of the Earning from trade(constant 2005 US) of Dominican Republic in 2006 to that in 2011?
Ensure brevity in your answer.  0.66. What is the ratio of the Earning from trade(constant 2005 US) in Egypt, Arab Rep. in 2006 to that in 2011?
Offer a terse response. 0.75. What is the ratio of the Earning from trade(constant 2005 US) in Other small states in 2006 to that in 2012?
Offer a very short reply. 0.88. What is the ratio of the Earning from trade(constant 2005 US) in Dominican Republic in 2006 to that in 2012?
Make the answer very short. 0.61. What is the ratio of the Earning from trade(constant 2005 US) in Egypt, Arab Rep. in 2006 to that in 2012?
Offer a very short reply. 0.77. What is the ratio of the Earning from trade(constant 2005 US) in Other small states in 2007 to that in 2008?
Provide a short and direct response. 1.04. What is the ratio of the Earning from trade(constant 2005 US) of Dominican Republic in 2007 to that in 2008?
Your answer should be very brief. 1.05. What is the ratio of the Earning from trade(constant 2005 US) in Egypt, Arab Rep. in 2007 to that in 2008?
Offer a terse response. 0.78. What is the ratio of the Earning from trade(constant 2005 US) of Other small states in 2007 to that in 2009?
Give a very brief answer. 1.13. What is the ratio of the Earning from trade(constant 2005 US) in Dominican Republic in 2007 to that in 2009?
Provide a succinct answer. 1.15. What is the ratio of the Earning from trade(constant 2005 US) in Egypt, Arab Rep. in 2007 to that in 2009?
Make the answer very short. 0.91. What is the ratio of the Earning from trade(constant 2005 US) in Other small states in 2007 to that in 2010?
Your answer should be compact. 1.06. What is the ratio of the Earning from trade(constant 2005 US) of Dominican Republic in 2007 to that in 2010?
Make the answer very short. 1.03. What is the ratio of the Earning from trade(constant 2005 US) of Egypt, Arab Rep. in 2007 to that in 2010?
Offer a very short reply. 0.94. What is the ratio of the Earning from trade(constant 2005 US) of Other small states in 2007 to that in 2011?
Provide a succinct answer. 0.99. What is the ratio of the Earning from trade(constant 2005 US) in Dominican Republic in 2007 to that in 2011?
Your answer should be very brief. 0.91. What is the ratio of the Earning from trade(constant 2005 US) of Egypt, Arab Rep. in 2007 to that in 2011?
Keep it short and to the point. 0.93. What is the ratio of the Earning from trade(constant 2005 US) of Other small states in 2007 to that in 2012?
Your response must be concise. 0.96. What is the ratio of the Earning from trade(constant 2005 US) of Dominican Republic in 2007 to that in 2012?
Ensure brevity in your answer.  0.84. What is the ratio of the Earning from trade(constant 2005 US) in Egypt, Arab Rep. in 2007 to that in 2012?
Provide a succinct answer. 0.95. What is the ratio of the Earning from trade(constant 2005 US) of Other small states in 2008 to that in 2009?
Ensure brevity in your answer.  1.08. What is the ratio of the Earning from trade(constant 2005 US) of Dominican Republic in 2008 to that in 2009?
Provide a short and direct response. 1.09. What is the ratio of the Earning from trade(constant 2005 US) in Egypt, Arab Rep. in 2008 to that in 2009?
Provide a short and direct response. 1.18. What is the ratio of the Earning from trade(constant 2005 US) of Other small states in 2008 to that in 2010?
Offer a terse response. 1.02. What is the ratio of the Earning from trade(constant 2005 US) in Dominican Republic in 2008 to that in 2010?
Your answer should be very brief. 0.98. What is the ratio of the Earning from trade(constant 2005 US) of Egypt, Arab Rep. in 2008 to that in 2010?
Offer a terse response. 1.21. What is the ratio of the Earning from trade(constant 2005 US) of Other small states in 2008 to that in 2011?
Offer a very short reply. 0.95. What is the ratio of the Earning from trade(constant 2005 US) in Dominican Republic in 2008 to that in 2011?
Keep it short and to the point. 0.87. What is the ratio of the Earning from trade(constant 2005 US) of Egypt, Arab Rep. in 2008 to that in 2011?
Give a very brief answer. 1.2. What is the ratio of the Earning from trade(constant 2005 US) of Other small states in 2008 to that in 2012?
Offer a very short reply. 0.92. What is the ratio of the Earning from trade(constant 2005 US) of Dominican Republic in 2008 to that in 2012?
Make the answer very short. 0.8. What is the ratio of the Earning from trade(constant 2005 US) in Egypt, Arab Rep. in 2008 to that in 2012?
Keep it short and to the point. 1.23. What is the ratio of the Earning from trade(constant 2005 US) of Other small states in 2009 to that in 2010?
Give a very brief answer. 0.94. What is the ratio of the Earning from trade(constant 2005 US) in Dominican Republic in 2009 to that in 2010?
Your response must be concise. 0.9. What is the ratio of the Earning from trade(constant 2005 US) of Egypt, Arab Rep. in 2009 to that in 2010?
Give a very brief answer. 1.03. What is the ratio of the Earning from trade(constant 2005 US) of Other small states in 2009 to that in 2011?
Offer a very short reply. 0.88. What is the ratio of the Earning from trade(constant 2005 US) of Dominican Republic in 2009 to that in 2011?
Your answer should be compact. 0.79. What is the ratio of the Earning from trade(constant 2005 US) in Egypt, Arab Rep. in 2009 to that in 2011?
Provide a succinct answer. 1.02. What is the ratio of the Earning from trade(constant 2005 US) in Other small states in 2009 to that in 2012?
Make the answer very short. 0.85. What is the ratio of the Earning from trade(constant 2005 US) in Dominican Republic in 2009 to that in 2012?
Your answer should be compact. 0.74. What is the ratio of the Earning from trade(constant 2005 US) of Egypt, Arab Rep. in 2009 to that in 2012?
Offer a terse response. 1.04. What is the ratio of the Earning from trade(constant 2005 US) of Other small states in 2010 to that in 2011?
Offer a terse response. 0.93. What is the ratio of the Earning from trade(constant 2005 US) of Dominican Republic in 2010 to that in 2011?
Ensure brevity in your answer.  0.89. What is the ratio of the Earning from trade(constant 2005 US) in Other small states in 2010 to that in 2012?
Offer a terse response. 0.91. What is the ratio of the Earning from trade(constant 2005 US) in Dominican Republic in 2010 to that in 2012?
Your answer should be compact. 0.82. What is the ratio of the Earning from trade(constant 2005 US) of Egypt, Arab Rep. in 2010 to that in 2012?
Offer a very short reply. 1.01. What is the ratio of the Earning from trade(constant 2005 US) of Other small states in 2011 to that in 2012?
Ensure brevity in your answer.  0.97. What is the ratio of the Earning from trade(constant 2005 US) in Dominican Republic in 2011 to that in 2012?
Offer a terse response. 0.93. What is the ratio of the Earning from trade(constant 2005 US) in Egypt, Arab Rep. in 2011 to that in 2012?
Your answer should be very brief. 1.02. What is the difference between the highest and the second highest Earning from trade(constant 2005 US) of Other small states?
Ensure brevity in your answer.  9.71e+08. What is the difference between the highest and the second highest Earning from trade(constant 2005 US) of Dominican Republic?
Provide a succinct answer. 1.27e+09. What is the difference between the highest and the second highest Earning from trade(constant 2005 US) of Egypt, Arab Rep.?
Keep it short and to the point. 7.84e+09. What is the difference between the highest and the lowest Earning from trade(constant 2005 US) in Other small states?
Offer a terse response. 5.89e+09. What is the difference between the highest and the lowest Earning from trade(constant 2005 US) of Dominican Republic?
Keep it short and to the point. 6.74e+09. What is the difference between the highest and the lowest Earning from trade(constant 2005 US) in Egypt, Arab Rep.?
Give a very brief answer. 2.52e+1. 